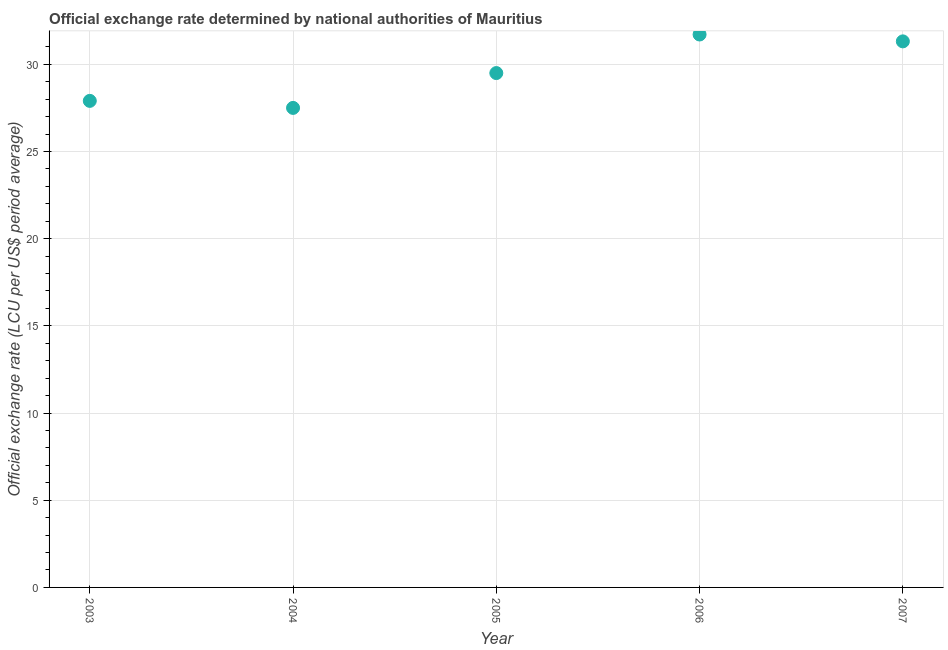What is the official exchange rate in 2003?
Offer a terse response. 27.9. Across all years, what is the maximum official exchange rate?
Make the answer very short. 31.71. Across all years, what is the minimum official exchange rate?
Your answer should be compact. 27.5. What is the sum of the official exchange rate?
Your response must be concise. 147.92. What is the difference between the official exchange rate in 2003 and 2007?
Ensure brevity in your answer.  -3.41. What is the average official exchange rate per year?
Keep it short and to the point. 29.58. What is the median official exchange rate?
Your response must be concise. 29.5. In how many years, is the official exchange rate greater than 29 ?
Make the answer very short. 3. Do a majority of the years between 2004 and 2003 (inclusive) have official exchange rate greater than 2 ?
Give a very brief answer. No. What is the ratio of the official exchange rate in 2003 to that in 2005?
Provide a short and direct response. 0.95. Is the official exchange rate in 2003 less than that in 2005?
Your answer should be compact. Yes. What is the difference between the highest and the second highest official exchange rate?
Your answer should be compact. 0.39. Is the sum of the official exchange rate in 2005 and 2007 greater than the maximum official exchange rate across all years?
Keep it short and to the point. Yes. What is the difference between the highest and the lowest official exchange rate?
Provide a short and direct response. 4.21. In how many years, is the official exchange rate greater than the average official exchange rate taken over all years?
Give a very brief answer. 2. Does the graph contain any zero values?
Give a very brief answer. No. What is the title of the graph?
Make the answer very short. Official exchange rate determined by national authorities of Mauritius. What is the label or title of the X-axis?
Ensure brevity in your answer.  Year. What is the label or title of the Y-axis?
Keep it short and to the point. Official exchange rate (LCU per US$ period average). What is the Official exchange rate (LCU per US$ period average) in 2003?
Provide a succinct answer. 27.9. What is the Official exchange rate (LCU per US$ period average) in 2004?
Your answer should be very brief. 27.5. What is the Official exchange rate (LCU per US$ period average) in 2005?
Ensure brevity in your answer.  29.5. What is the Official exchange rate (LCU per US$ period average) in 2006?
Make the answer very short. 31.71. What is the Official exchange rate (LCU per US$ period average) in 2007?
Your answer should be compact. 31.31. What is the difference between the Official exchange rate (LCU per US$ period average) in 2003 and 2004?
Provide a short and direct response. 0.4. What is the difference between the Official exchange rate (LCU per US$ period average) in 2003 and 2005?
Ensure brevity in your answer.  -1.59. What is the difference between the Official exchange rate (LCU per US$ period average) in 2003 and 2006?
Your answer should be very brief. -3.81. What is the difference between the Official exchange rate (LCU per US$ period average) in 2003 and 2007?
Your response must be concise. -3.41. What is the difference between the Official exchange rate (LCU per US$ period average) in 2004 and 2005?
Make the answer very short. -2. What is the difference between the Official exchange rate (LCU per US$ period average) in 2004 and 2006?
Your response must be concise. -4.21. What is the difference between the Official exchange rate (LCU per US$ period average) in 2004 and 2007?
Your response must be concise. -3.82. What is the difference between the Official exchange rate (LCU per US$ period average) in 2005 and 2006?
Your response must be concise. -2.21. What is the difference between the Official exchange rate (LCU per US$ period average) in 2005 and 2007?
Offer a terse response. -1.82. What is the difference between the Official exchange rate (LCU per US$ period average) in 2006 and 2007?
Provide a short and direct response. 0.39. What is the ratio of the Official exchange rate (LCU per US$ period average) in 2003 to that in 2004?
Keep it short and to the point. 1.01. What is the ratio of the Official exchange rate (LCU per US$ period average) in 2003 to that in 2005?
Offer a very short reply. 0.95. What is the ratio of the Official exchange rate (LCU per US$ period average) in 2003 to that in 2007?
Make the answer very short. 0.89. What is the ratio of the Official exchange rate (LCU per US$ period average) in 2004 to that in 2005?
Offer a very short reply. 0.93. What is the ratio of the Official exchange rate (LCU per US$ period average) in 2004 to that in 2006?
Ensure brevity in your answer.  0.87. What is the ratio of the Official exchange rate (LCU per US$ period average) in 2004 to that in 2007?
Offer a very short reply. 0.88. What is the ratio of the Official exchange rate (LCU per US$ period average) in 2005 to that in 2007?
Offer a terse response. 0.94. 